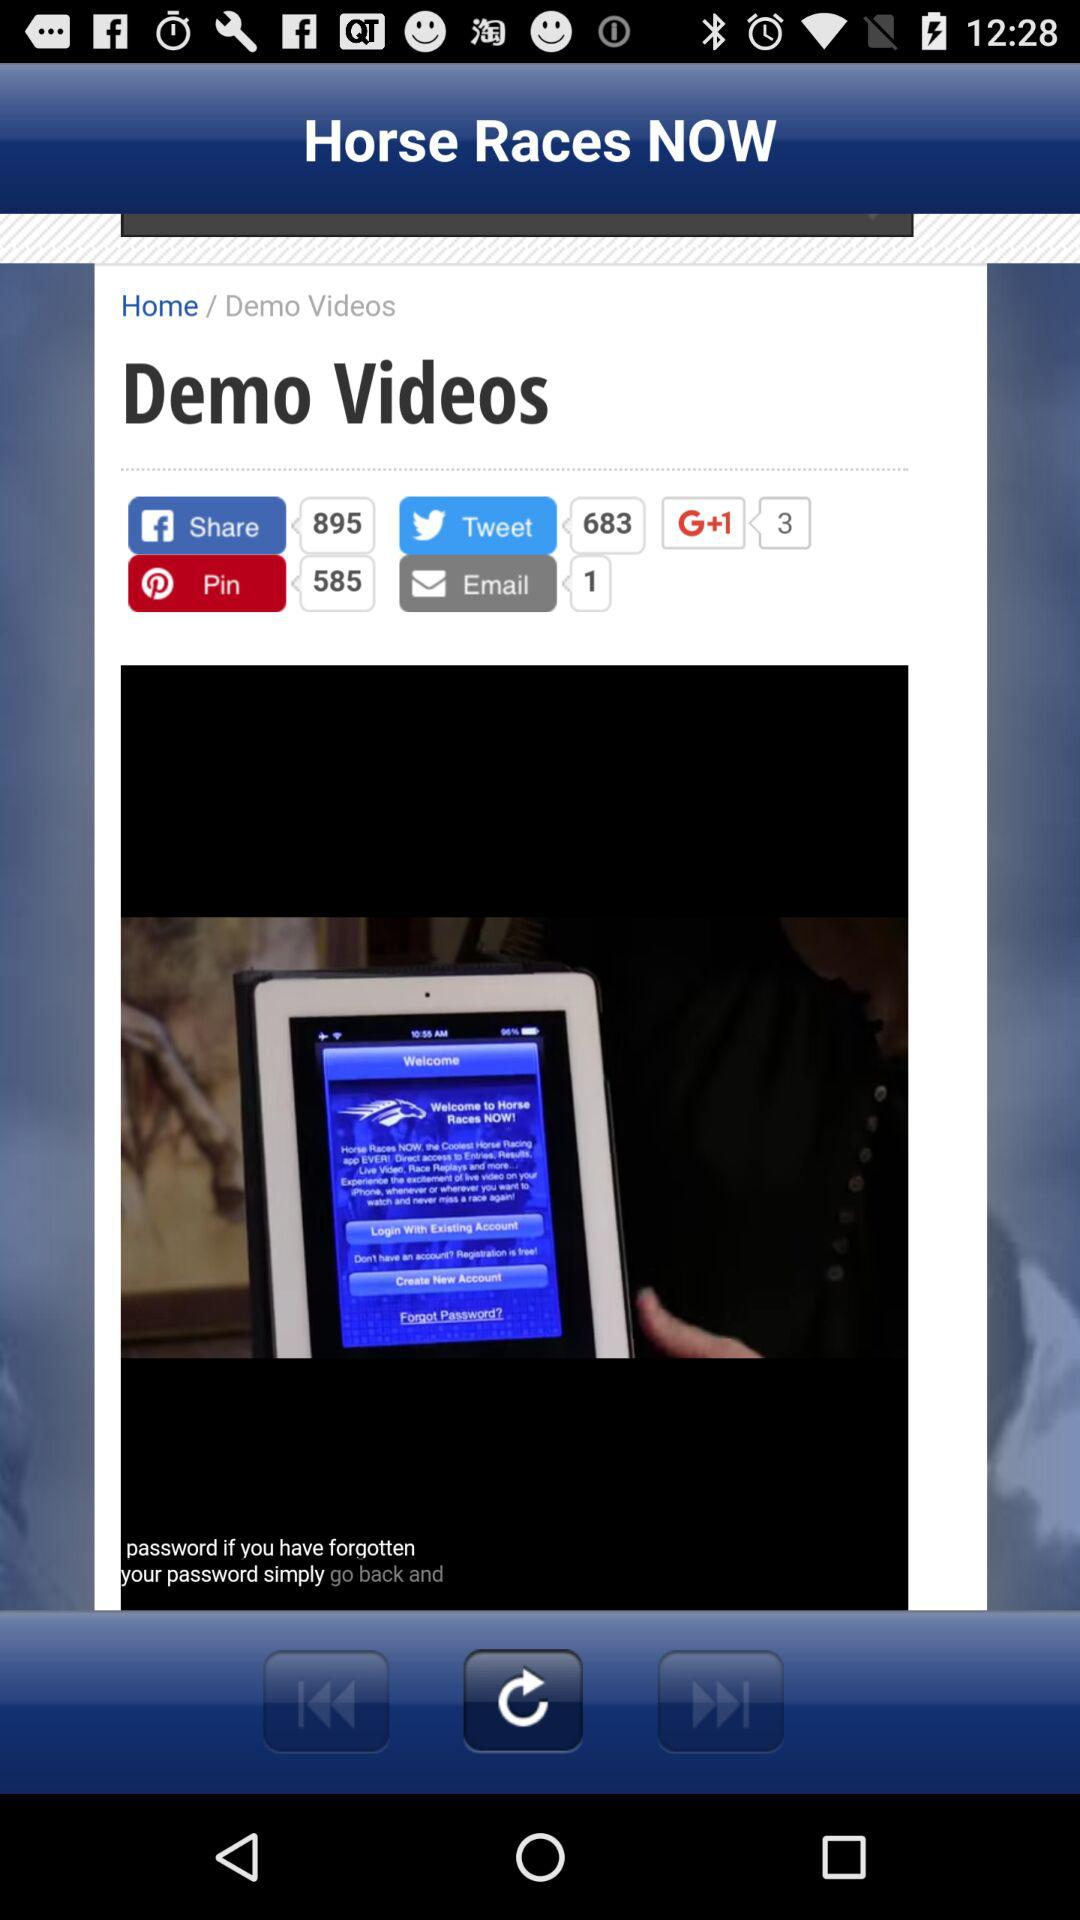Which social media platform has the item been shared on 683 times? The social media platform is "Twitter". 